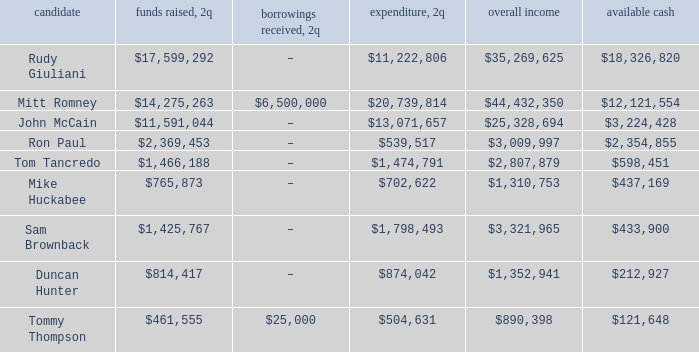Tell me the money raised when 2Q has total receipts of $890,398 $461,555. 